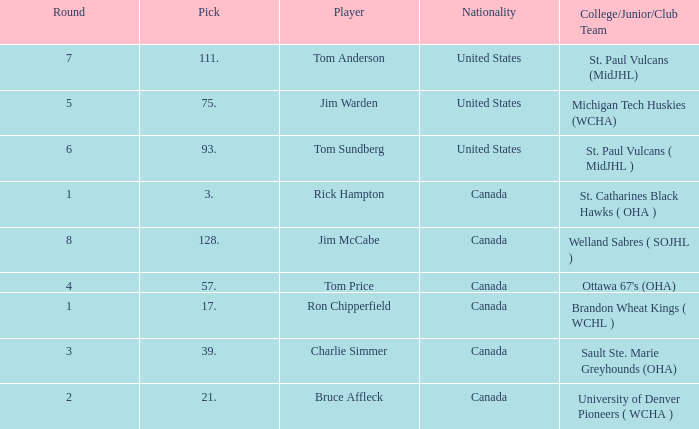Can you tell me the College/Junior/Club Team that has the Round of 4? Ottawa 67's (OHA). 